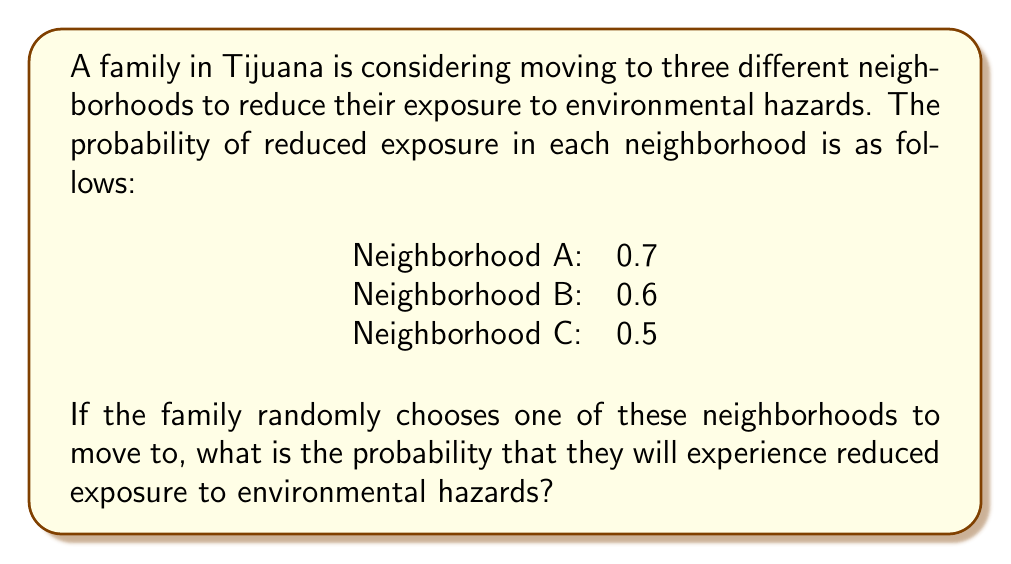Can you solve this math problem? To solve this problem, we'll use the concept of total probability. Since the family is randomly choosing one of the three neighborhoods, we can assume that each neighborhood has an equal probability of being selected, which is $\frac{1}{3}$.

Let's define the events:
$R$: Reduced exposure to environmental hazards
$A$: Choose Neighborhood A
$B$: Choose Neighborhood B
$C$: Choose Neighborhood C

We're given:
$P(R|A) = 0.7$
$P(R|B) = 0.6$
$P(R|C) = 0.5$
$P(A) = P(B) = P(C) = \frac{1}{3}$

Using the law of total probability:

$$P(R) = P(R|A)P(A) + P(R|B)P(B) + P(R|C)P(C)$$

Substituting the values:

$$P(R) = 0.7 \cdot \frac{1}{3} + 0.6 \cdot \frac{1}{3} + 0.5 \cdot \frac{1}{3}$$

$$P(R) = \frac{0.7 + 0.6 + 0.5}{3}$$

$$P(R) = \frac{1.8}{3} = 0.6$$

Therefore, the probability that the family will experience reduced exposure to environmental hazards is 0.6 or 60%.
Answer: 0.6 or 60% 